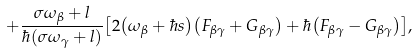<formula> <loc_0><loc_0><loc_500><loc_500>+ { \frac { \sigma \omega _ { \beta } + l } { \hbar { \left ( \sigma \omega _ { \gamma } + l \right ) } } } { \left [ 2 { \left ( \omega _ { \beta } + \hbar { s } \right ) } { \left ( F _ { \beta \gamma } + G _ { \beta \gamma } \right ) } + \hbar { \left ( F _ { \beta \gamma } - G _ { \beta \gamma } \right ) } \right ] } ,</formula> 